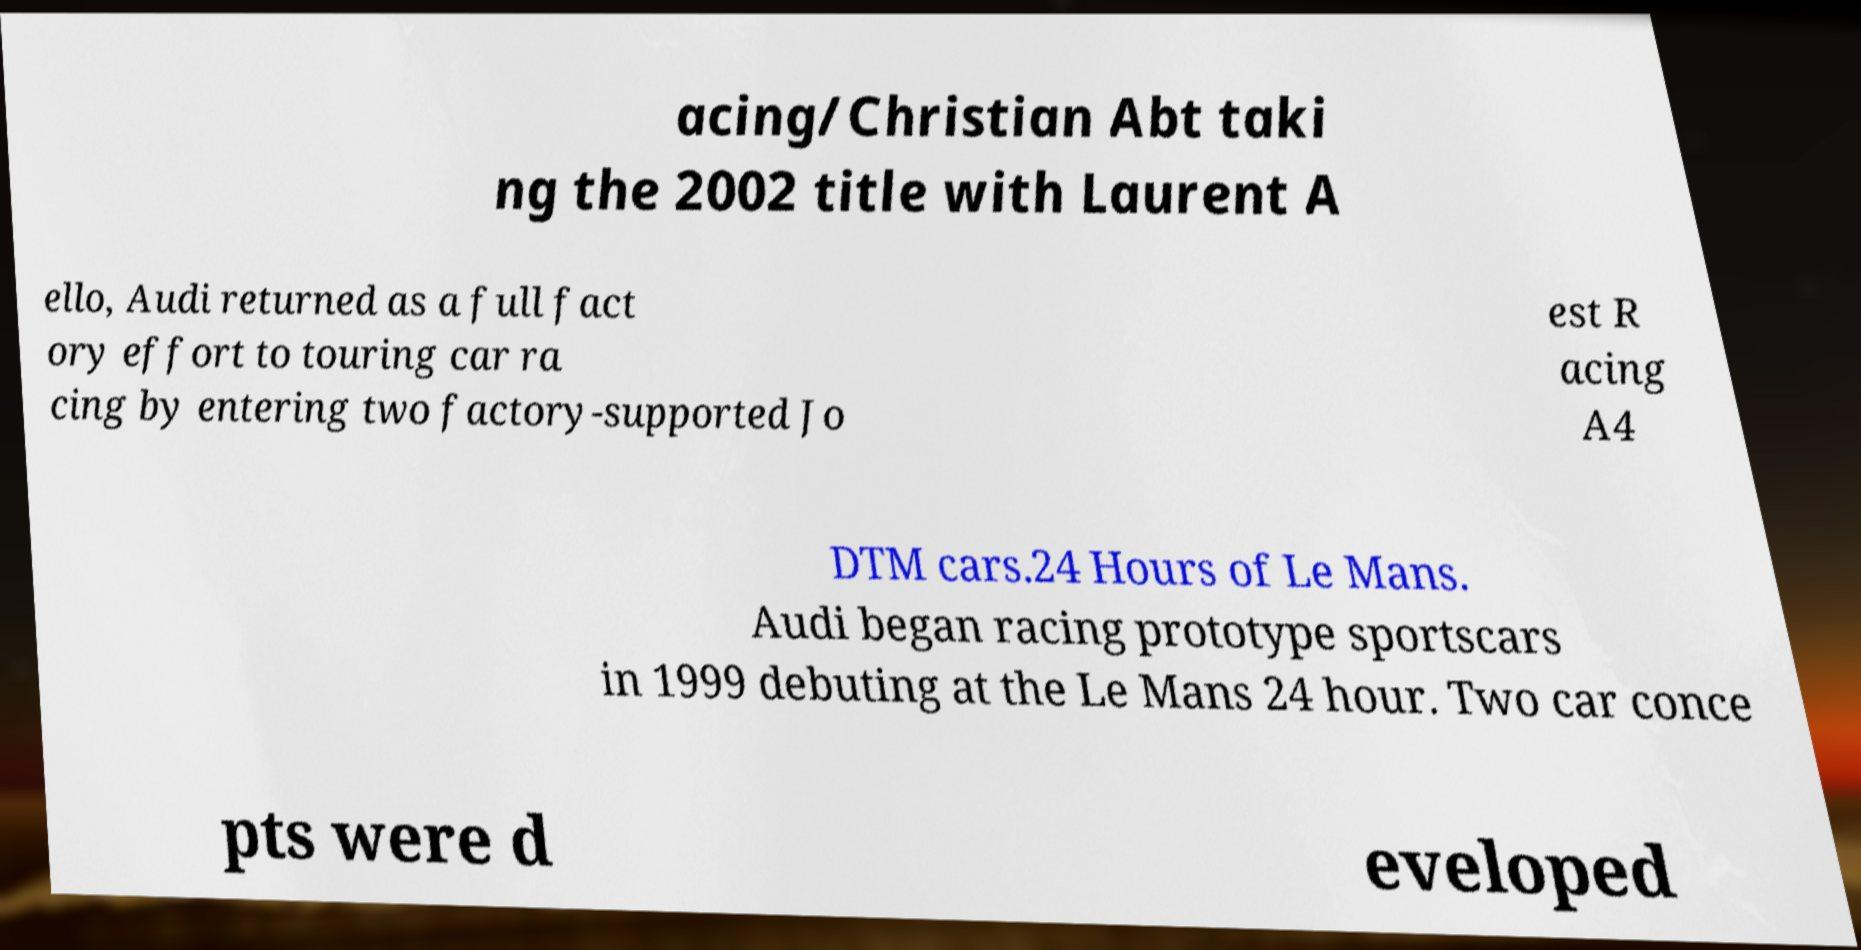Can you accurately transcribe the text from the provided image for me? acing/Christian Abt taki ng the 2002 title with Laurent A ello, Audi returned as a full fact ory effort to touring car ra cing by entering two factory-supported Jo est R acing A4 DTM cars.24 Hours of Le Mans. Audi began racing prototype sportscars in 1999 debuting at the Le Mans 24 hour. Two car conce pts were d eveloped 